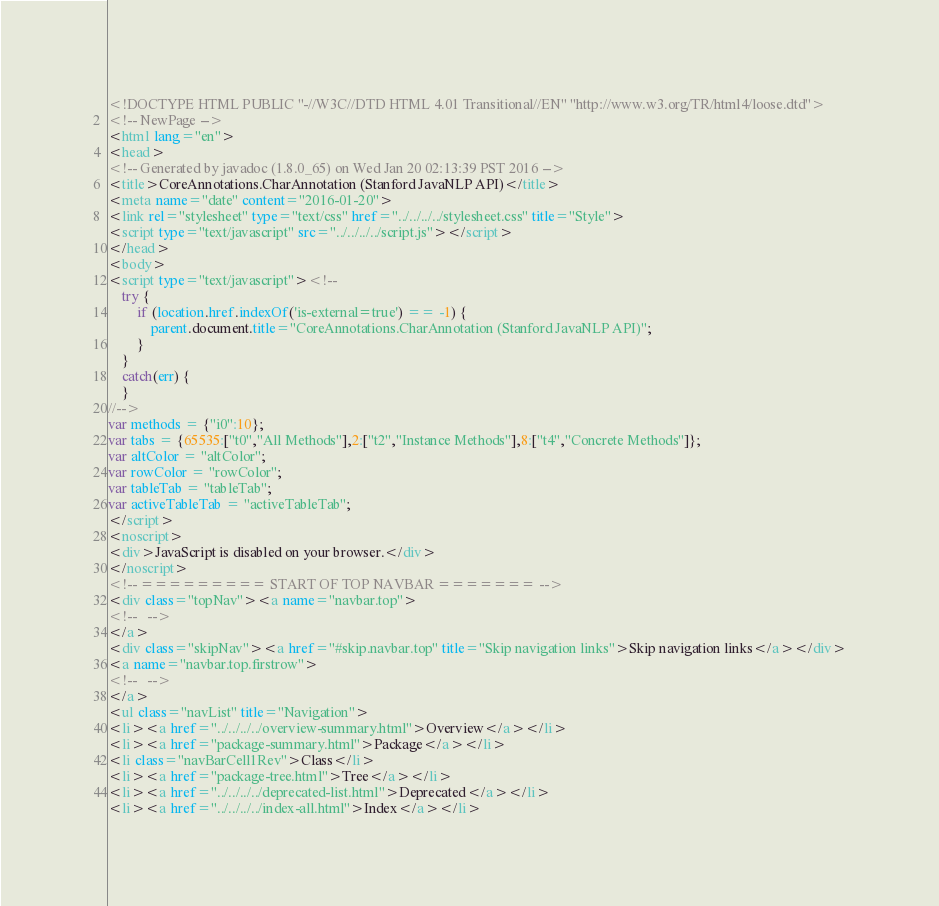Convert code to text. <code><loc_0><loc_0><loc_500><loc_500><_HTML_><!DOCTYPE HTML PUBLIC "-//W3C//DTD HTML 4.01 Transitional//EN" "http://www.w3.org/TR/html4/loose.dtd">
<!-- NewPage -->
<html lang="en">
<head>
<!-- Generated by javadoc (1.8.0_65) on Wed Jan 20 02:13:39 PST 2016 -->
<title>CoreAnnotations.CharAnnotation (Stanford JavaNLP API)</title>
<meta name="date" content="2016-01-20">
<link rel="stylesheet" type="text/css" href="../../../../stylesheet.css" title="Style">
<script type="text/javascript" src="../../../../script.js"></script>
</head>
<body>
<script type="text/javascript"><!--
    try {
        if (location.href.indexOf('is-external=true') == -1) {
            parent.document.title="CoreAnnotations.CharAnnotation (Stanford JavaNLP API)";
        }
    }
    catch(err) {
    }
//-->
var methods = {"i0":10};
var tabs = {65535:["t0","All Methods"],2:["t2","Instance Methods"],8:["t4","Concrete Methods"]};
var altColor = "altColor";
var rowColor = "rowColor";
var tableTab = "tableTab";
var activeTableTab = "activeTableTab";
</script>
<noscript>
<div>JavaScript is disabled on your browser.</div>
</noscript>
<!-- ========= START OF TOP NAVBAR ======= -->
<div class="topNav"><a name="navbar.top">
<!--   -->
</a>
<div class="skipNav"><a href="#skip.navbar.top" title="Skip navigation links">Skip navigation links</a></div>
<a name="navbar.top.firstrow">
<!--   -->
</a>
<ul class="navList" title="Navigation">
<li><a href="../../../../overview-summary.html">Overview</a></li>
<li><a href="package-summary.html">Package</a></li>
<li class="navBarCell1Rev">Class</li>
<li><a href="package-tree.html">Tree</a></li>
<li><a href="../../../../deprecated-list.html">Deprecated</a></li>
<li><a href="../../../../index-all.html">Index</a></li></code> 